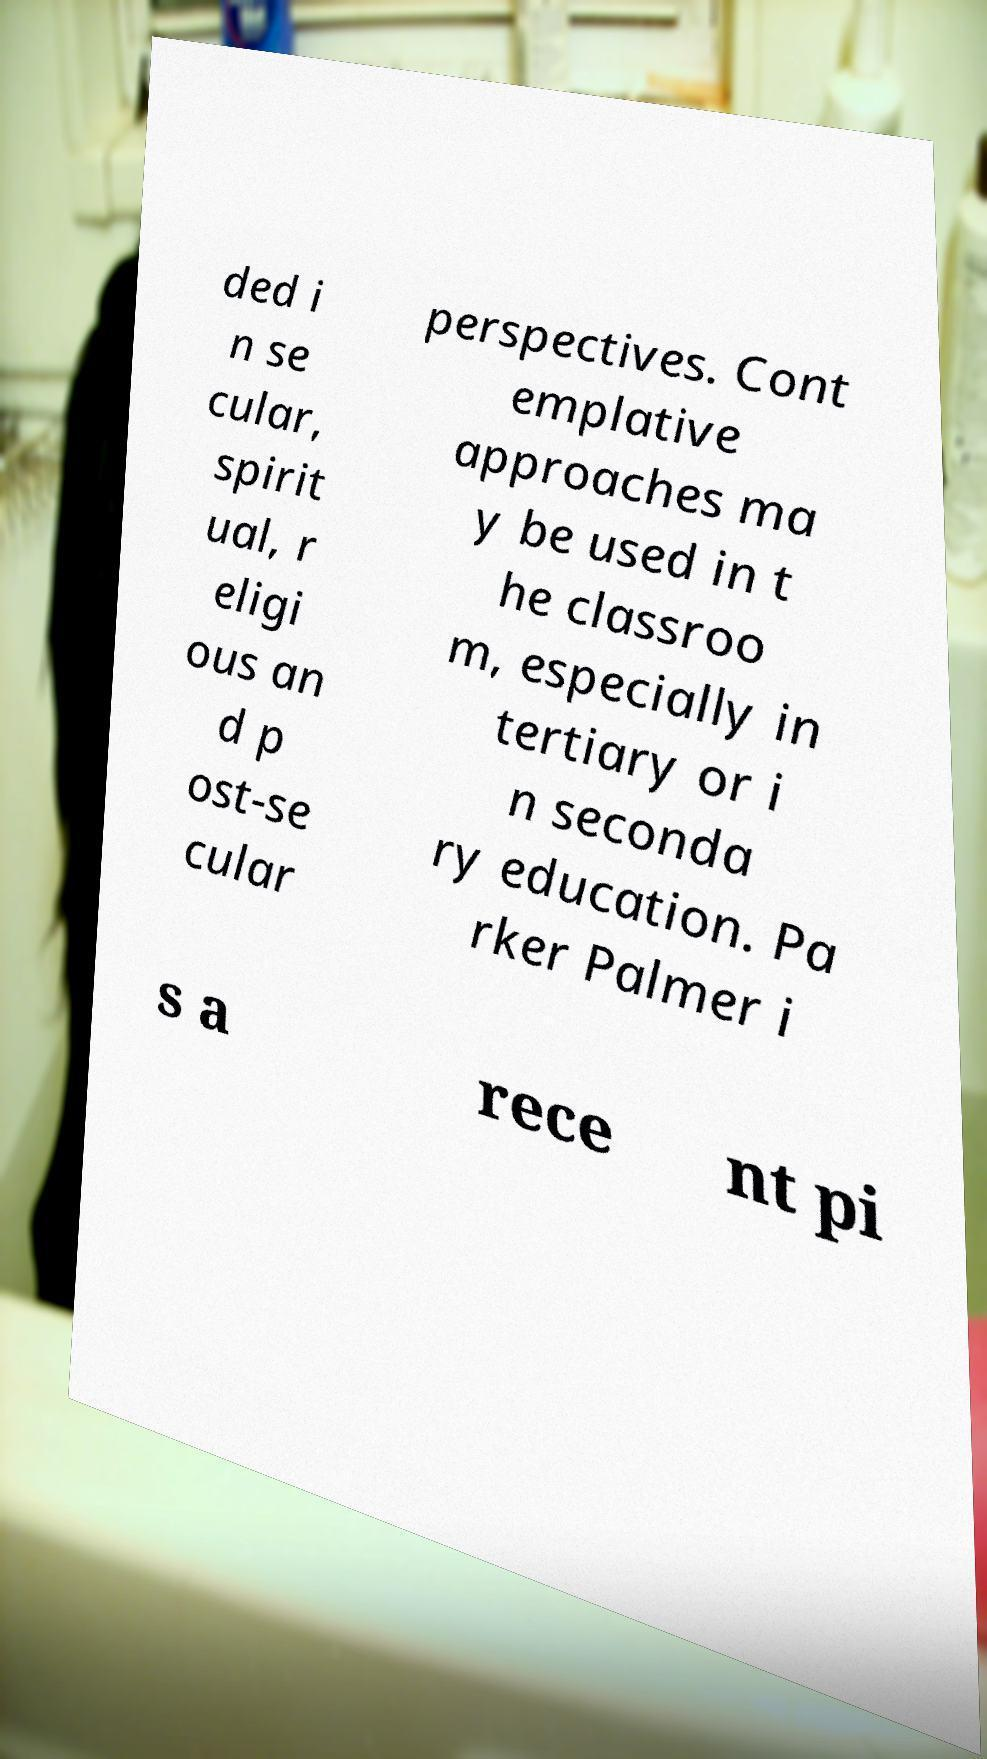Please identify and transcribe the text found in this image. ded i n se cular, spirit ual, r eligi ous an d p ost-se cular perspectives. Cont emplative approaches ma y be used in t he classroo m, especially in tertiary or i n seconda ry education. Pa rker Palmer i s a rece nt pi 